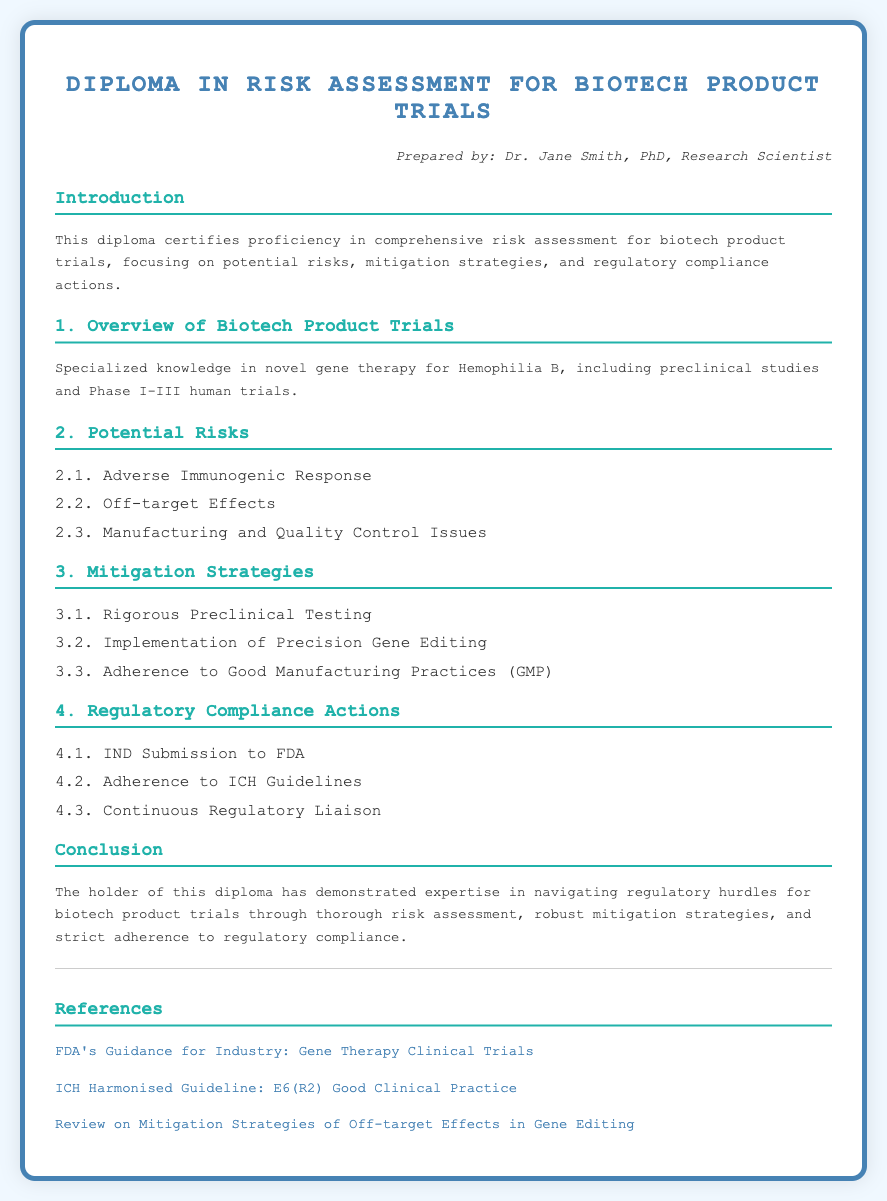What is the title of the diploma? The title of the diploma is stated at the top of the document.
Answer: Diploma in Risk Assessment for Biotech Product Trials Who prepared the diploma? The author of the diploma is mentioned in the author section.
Answer: Dr. Jane Smith What is one potential risk listed in the document? The document provides a list of potential risks associated with biotech product trials.
Answer: Adverse Immunogenic Response What is one mitigation strategy mentioned? The strategies for mitigating risks are listed in the document.
Answer: Rigorous Preclinical Testing What regulatory compliance action is recommended? The document enumerates regulatory compliance actions that must be taken.
Answer: IND Submission to FDA What phase of trials does the overview specifically mention? The phase of trials included in the overview section is specified.
Answer: Phase I-III How many total potential risks are listed? The document includes a list of potential risks; counting them gives the total.
Answer: 3 What type of gene therapy is discussed in the introduction? The introduction specifies the type of gene therapy being assessed.
Answer: Gene therapy for Hemophilia B What is emphasized in the conclusion about the diploma holder? The conclusion highlights key skills or knowledge the diploma holder possesses.
Answer: Expertise in navigating regulatory hurdles 